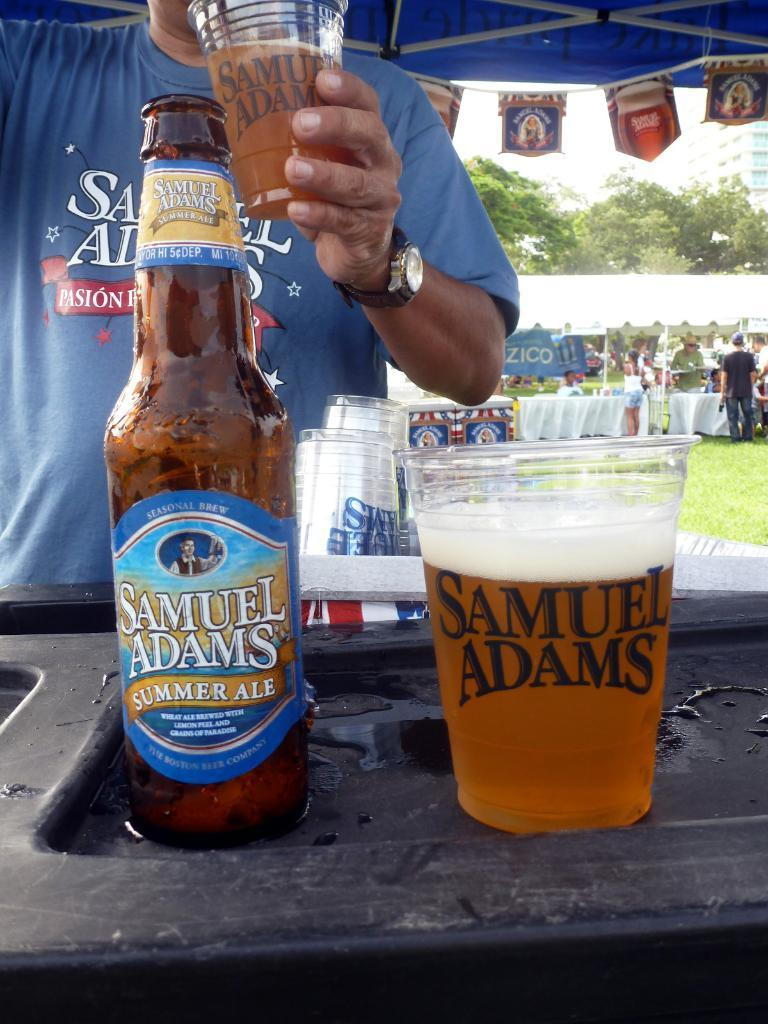<image>
Summarize the visual content of the image. A samuel adams summer ale bottle next to a cup of the same name 